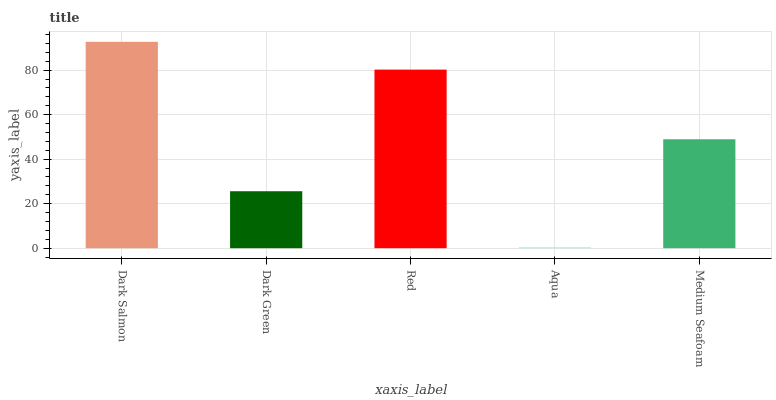Is Aqua the minimum?
Answer yes or no. Yes. Is Dark Salmon the maximum?
Answer yes or no. Yes. Is Dark Green the minimum?
Answer yes or no. No. Is Dark Green the maximum?
Answer yes or no. No. Is Dark Salmon greater than Dark Green?
Answer yes or no. Yes. Is Dark Green less than Dark Salmon?
Answer yes or no. Yes. Is Dark Green greater than Dark Salmon?
Answer yes or no. No. Is Dark Salmon less than Dark Green?
Answer yes or no. No. Is Medium Seafoam the high median?
Answer yes or no. Yes. Is Medium Seafoam the low median?
Answer yes or no. Yes. Is Dark Green the high median?
Answer yes or no. No. Is Dark Salmon the low median?
Answer yes or no. No. 